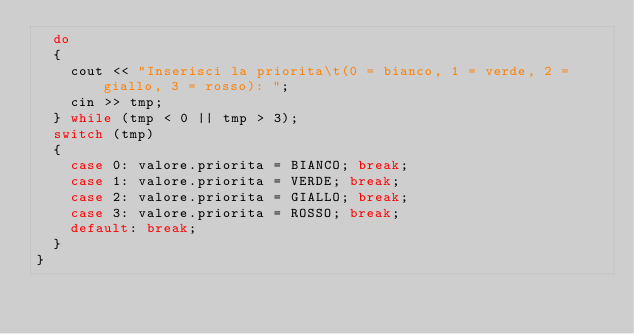<code> <loc_0><loc_0><loc_500><loc_500><_C++_>	do
	{
		cout << "Inserisci la priorita\t(0 = bianco, 1 = verde, 2 = giallo, 3 = rosso): ";
		cin >> tmp;
	} while (tmp < 0 || tmp > 3);
	switch (tmp)
	{
		case 0: valore.priorita = BIANCO; break;
		case 1: valore.priorita = VERDE; break;
		case 2: valore.priorita = GIALLO; break;
		case 3: valore.priorita = ROSSO; break;
		default: break;
	}
}</code> 